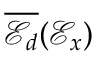<formula> <loc_0><loc_0><loc_500><loc_500>\overline { { \ m a t h s c r { E } _ { d } } } ( \mathcal { E } _ { x } )</formula> 